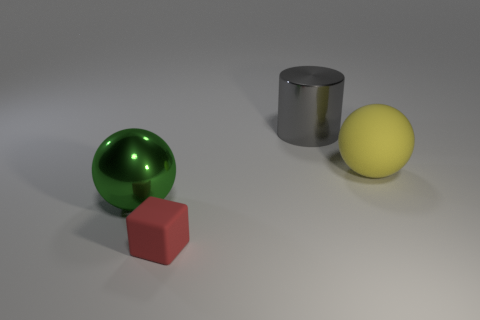What shape is the yellow rubber object that is the same size as the green shiny sphere? sphere 